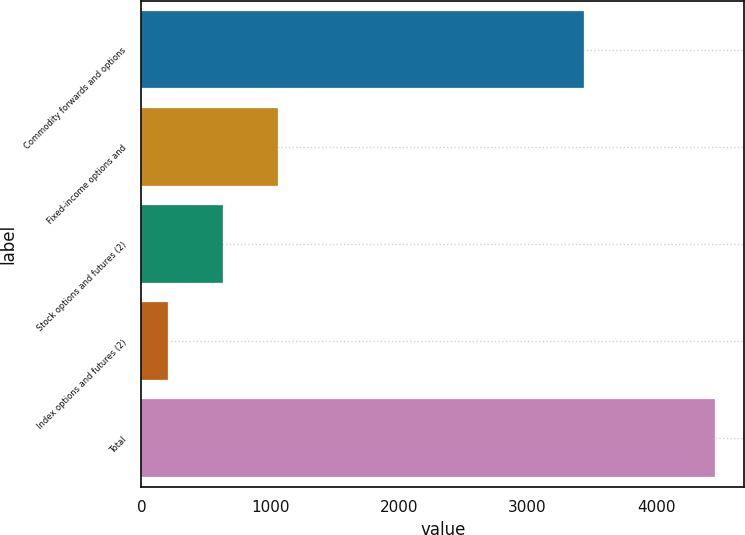Convert chart to OTSL. <chart><loc_0><loc_0><loc_500><loc_500><bar_chart><fcel>Commodity forwards and options<fcel>Fixed-income options and<fcel>Stock options and futures (2)<fcel>Index options and futures (2)<fcel>Total<nl><fcel>3437<fcel>1058.4<fcel>633.2<fcel>208<fcel>4460<nl></chart> 